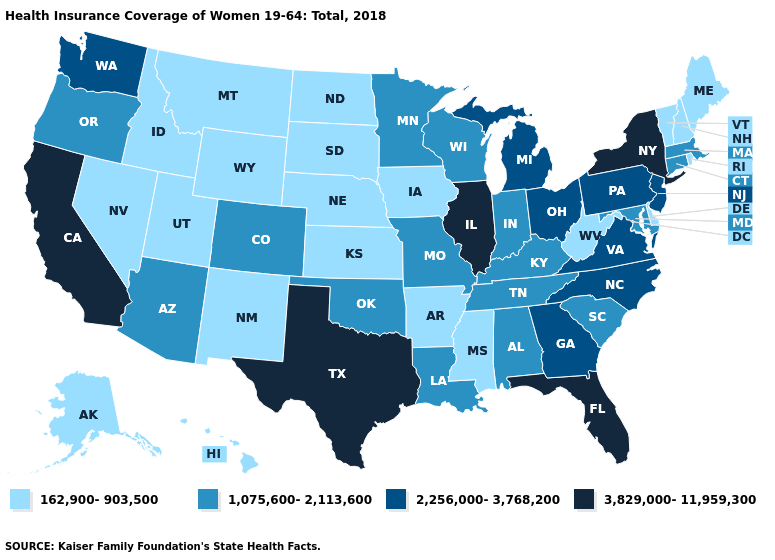What is the value of Tennessee?
Be succinct. 1,075,600-2,113,600. What is the value of Arizona?
Be succinct. 1,075,600-2,113,600. Does the first symbol in the legend represent the smallest category?
Concise answer only. Yes. Does Oregon have the highest value in the USA?
Concise answer only. No. Name the states that have a value in the range 3,829,000-11,959,300?
Keep it brief. California, Florida, Illinois, New York, Texas. What is the lowest value in the USA?
Concise answer only. 162,900-903,500. What is the lowest value in the USA?
Concise answer only. 162,900-903,500. What is the highest value in states that border Colorado?
Write a very short answer. 1,075,600-2,113,600. What is the value of Idaho?
Write a very short answer. 162,900-903,500. What is the lowest value in states that border Montana?
Keep it brief. 162,900-903,500. Does North Carolina have a higher value than North Dakota?
Short answer required. Yes. What is the value of Missouri?
Answer briefly. 1,075,600-2,113,600. What is the value of West Virginia?
Keep it brief. 162,900-903,500. What is the value of Georgia?
Concise answer only. 2,256,000-3,768,200. Which states hav the highest value in the MidWest?
Be succinct. Illinois. 